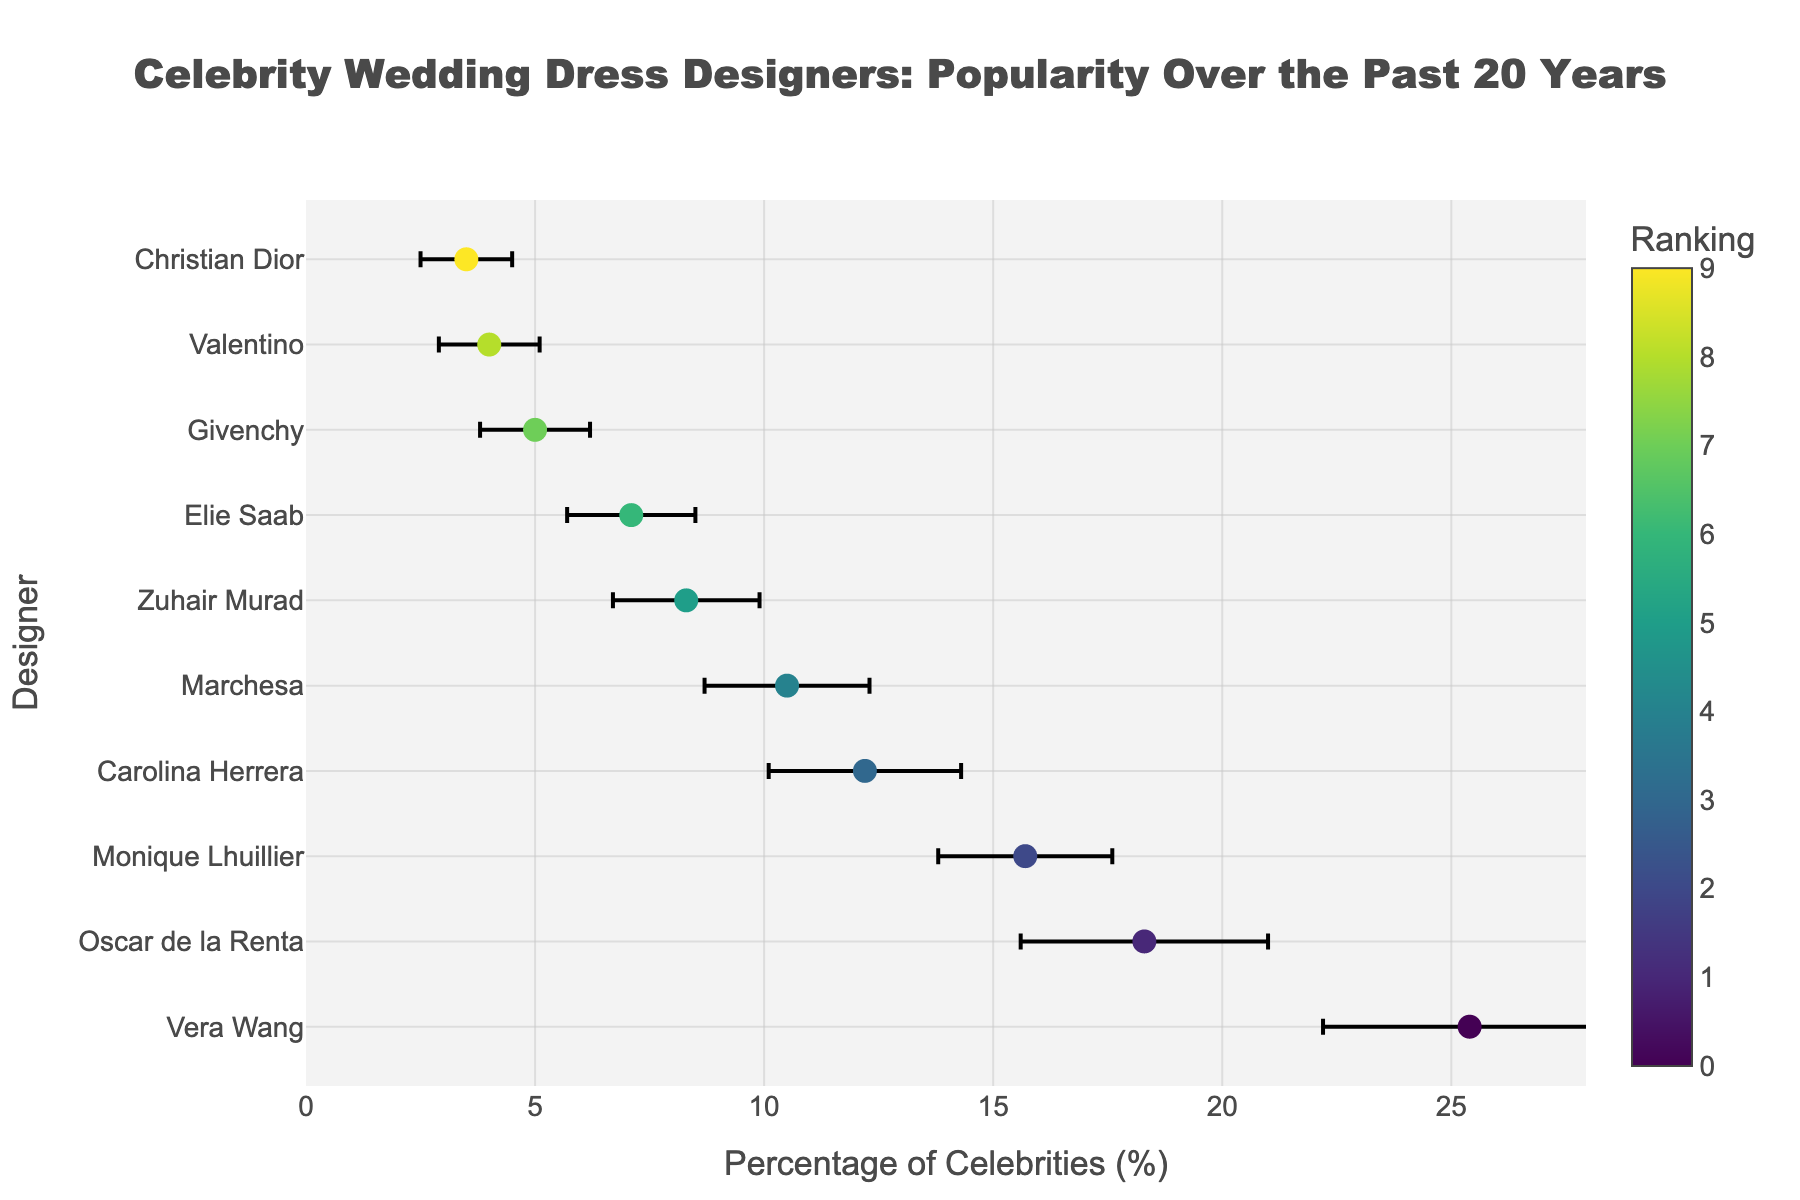What's the title of the figure? The title of the figure is prominently displayed at the top, centralized and readable. It is meant to provide context for the plot, indicating what the plot represents.
Answer: Celebrity Wedding Dress Designers: Popularity Over the Past 20 Years Which designer has the highest mean percentage of celebrities wearing their dresses? By examining the x-values aligned with the designers on the y-axis, the designer with the highest mean percentage will be at the far right.
Answer: Vera Wang What's the average mean percentage of the top 3 wedding dress designers in the figure? The top 3 designers based on mean percentage are Vera Wang (25.4%), Oscar de la Renta (18.3%), and Monique Lhuillier (15.7%). Adding their percentages and dividing by 3 gives (25.4 + 18.3 + 15.7)/3 = 59.4/3 = 19.8%.
Answer: 19.8% How does the percentage of celebrities wearing Carolina Herrera compare to those wearing Marchesa? Carolina Herrera has a mean percentage of 12.2%, while Marchesa has a mean percentage of 10.5%. By comparing these values, Carolina Herrera has a higher mean percentage than Marchesa.
Answer: Carolina Herrera is higher Which designer has the least mean percentage of celebrities wearing their dresses, and what is that percentage? The least mean percentage can be deduced by finding the designer with the smallest x-value on the plot.
Answer: Christian Dior, 3.5% What is the error range (mean ± std dev) for Vera Wang's percentage? Vera Wang's mean percentage is 25.4% with a standard deviation of 3.2%. The error range is from (25.4 - 3.2) to (25.4 + 3.2), i.e., 22.2% to 28.6%.
Answer: 22.2%-28.6% Between Elie Saab and Givenchy, which designer has a greater variability in the percentage of celebrities wearing their dresses? The standard deviations indicate variability. Elie Saab has a standard deviation of 1.4 and Givenchy has a standard deviation of 1.2. Therefore, Elie Saab has greater variability.
Answer: Elie Saab What is the difference in mean percentage between the top designer and the bottom designer? The top designer (Vera Wang) has a mean percentage of 25.4, and the bottom designer (Christian Dior) has 3.5. The difference is 25.4 - 3.5 = 21.9.
Answer: 21.9 If a designer has a mean percentage and standard deviation summing to more than 20, list those designers. By adding mean percentage and standard deviation for each designer and checking which sums exceed 20:
- Vera Wang: 25.4 + 3.2 = 28.6
- Oscar de la Renta: 18.3 + 2.7 = 21.0
- Monique Lhuillier: 15.7 + 1.9 = 17.6 (not over 20)
So, the designers are Vera Wang and Oscar de la Renta.
Answer: Vera Wang, Oscar de la Renta What is the combined percentage of celebrities wearing Zuhair Murad, Elie Saab, and Givenchy dresses? Sum the mean percentages for these designers: Zuhair Murad (8.3%), Elie Saab (7.1%), and Givenchy (5.0%). The combined percentage is 8.3 + 7.1 + 5.0 = 20.4%.
Answer: 20.4% 